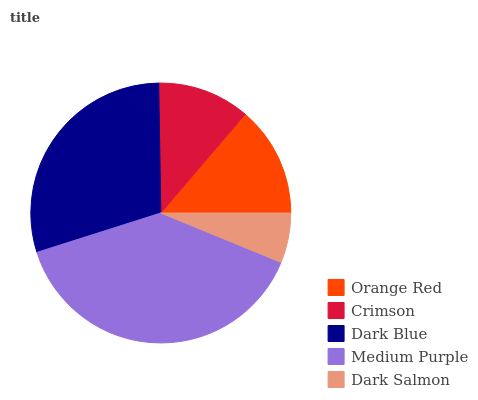Is Dark Salmon the minimum?
Answer yes or no. Yes. Is Medium Purple the maximum?
Answer yes or no. Yes. Is Crimson the minimum?
Answer yes or no. No. Is Crimson the maximum?
Answer yes or no. No. Is Orange Red greater than Crimson?
Answer yes or no. Yes. Is Crimson less than Orange Red?
Answer yes or no. Yes. Is Crimson greater than Orange Red?
Answer yes or no. No. Is Orange Red less than Crimson?
Answer yes or no. No. Is Orange Red the high median?
Answer yes or no. Yes. Is Orange Red the low median?
Answer yes or no. Yes. Is Medium Purple the high median?
Answer yes or no. No. Is Dark Salmon the low median?
Answer yes or no. No. 